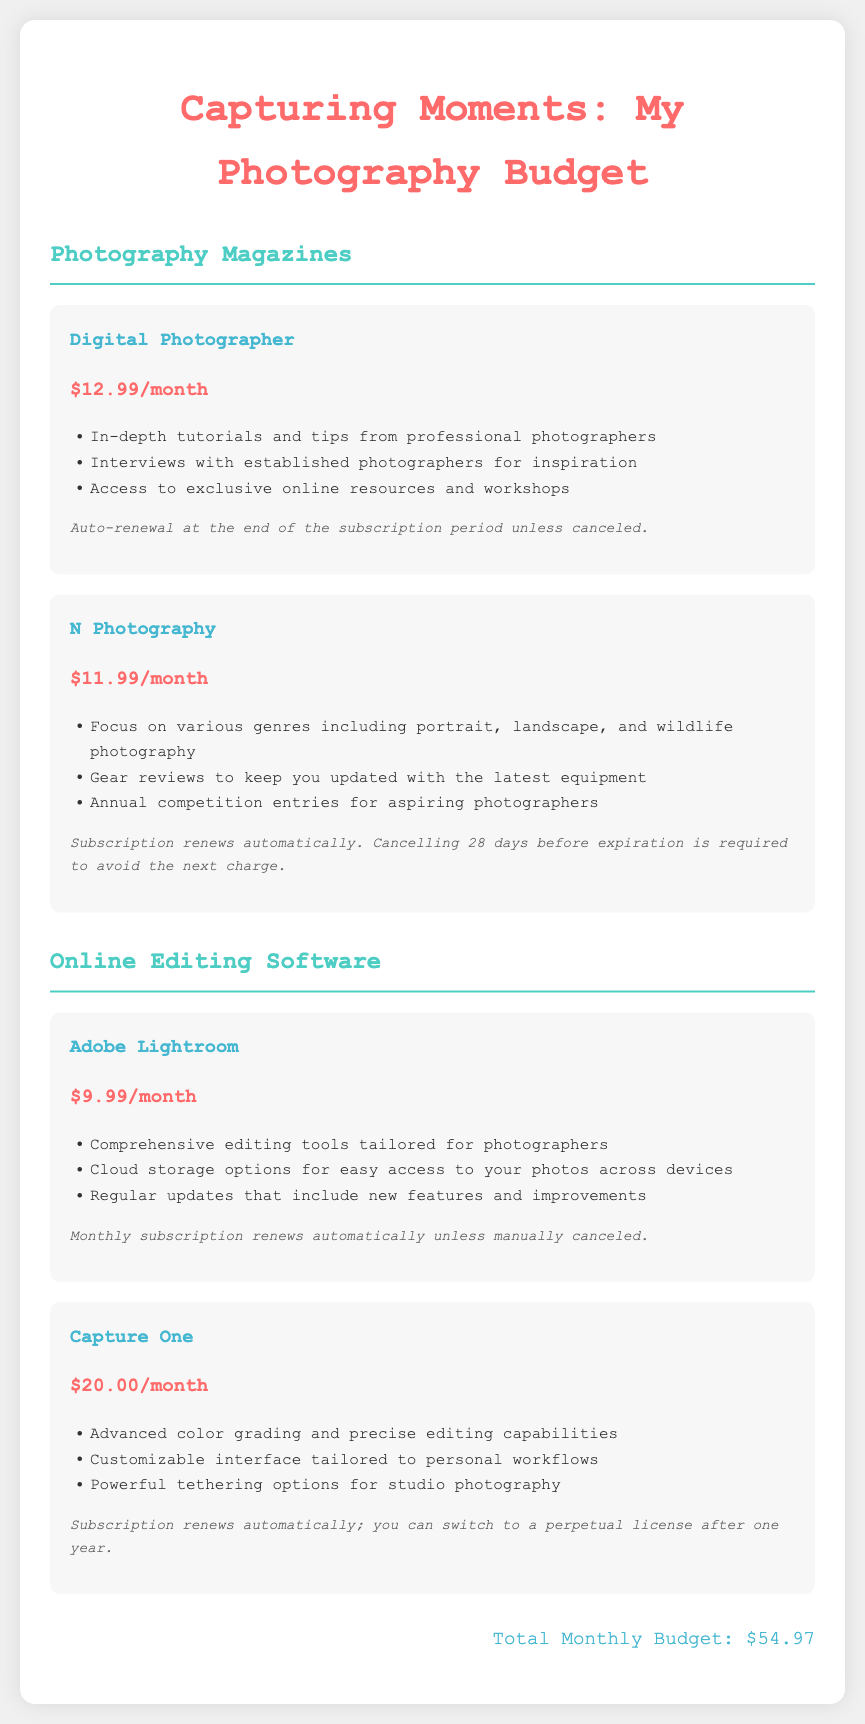What is the subscription cost for Digital Photographer? The subscription cost for Digital Photographer is listed in the document as $12.99/month.
Answer: $12.99/month How many photography magazines are included in the budget? The budget lists a total of two photography magazines.
Answer: 2 What features are provided by Adobe Lightroom? Adobe Lightroom offers comprehensive editing tools tailored for photographers, cloud storage options, and regular updates.
Answer: Comprehensive editing tools, cloud storage, regular updates What is the auto-renewal condition for N Photography? N Photography requires cancellation 28 days before expiration to avoid the next charge.
Answer: 28 days What is the total monthly budget for photography resources? The total monthly budget is the sum of all magazine and software subscriptions in the document, which amounts to $54.97.
Answer: $54.97 Which software offers advanced color grading capabilities? The software that provides advanced color grading capabilities is Capture One.
Answer: Capture One What is the monthly subscription cost for Capture One? The document states that Capture One's monthly subscription cost is $20.00.
Answer: $20.00 What must be done to cancel the Adobe Lightroom subscription? The Adobe Lightroom subscription must be manually canceled to stop auto-renewal.
Answer: Manually canceled 